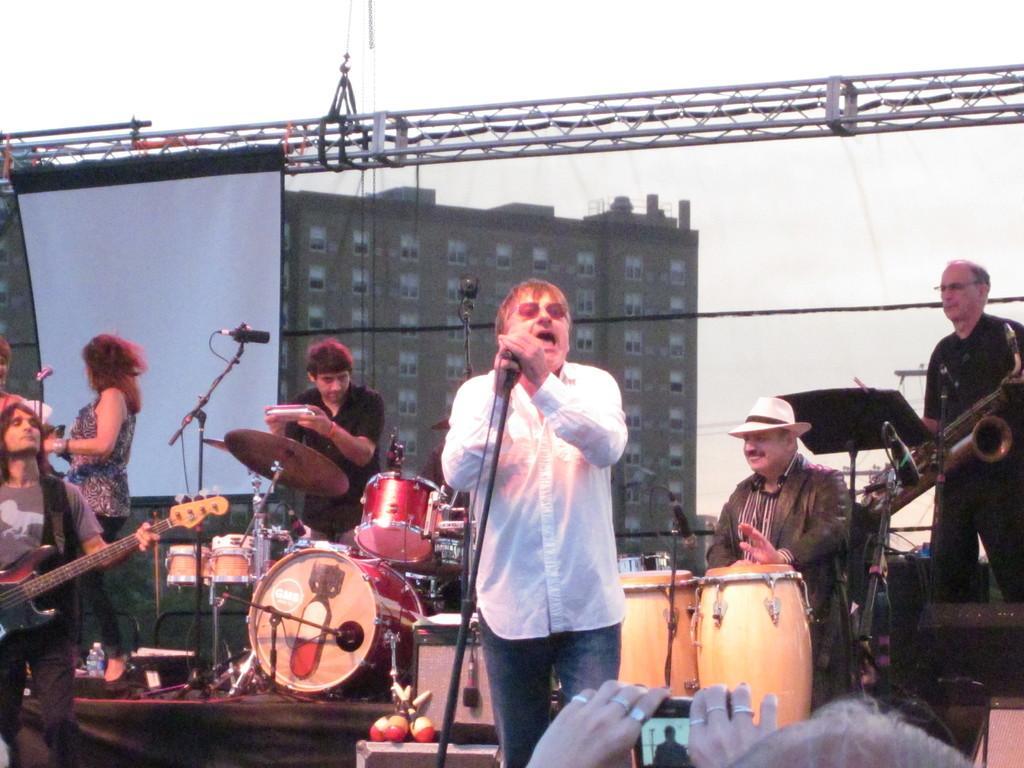Describe this image in one or two sentences. this picture shows a man standing and singing with the help of a microphone and a person playing an instrument and a person playing drums and a person playing guitar and we see a building back of them and a projector screen hanging 